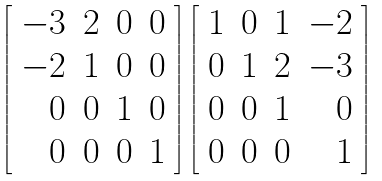Convert formula to latex. <formula><loc_0><loc_0><loc_500><loc_500>\left [ \begin{array} { r r r r } - 3 & 2 & 0 & 0 \\ - 2 & 1 & 0 & 0 \\ 0 & 0 & 1 & 0 \\ 0 & 0 & 0 & 1 \end{array} \right ] \left [ \begin{array} { r r r r } 1 & 0 & 1 & - 2 \\ 0 & 1 & 2 & - 3 \\ 0 & 0 & 1 & 0 \\ 0 & 0 & 0 & 1 \end{array} \right ]</formula> 